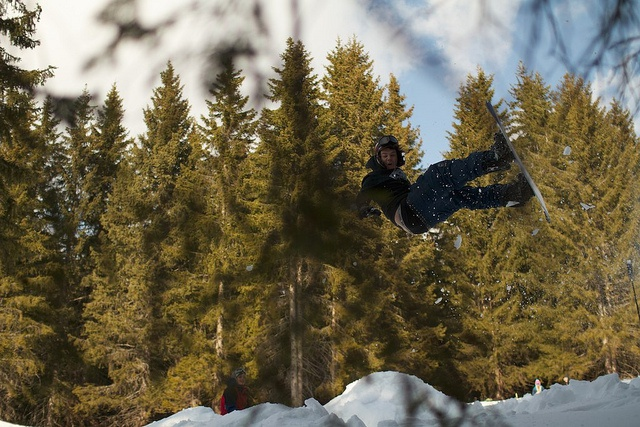Describe the objects in this image and their specific colors. I can see people in beige, black, gray, and olive tones and snowboard in beige, gray, darkgray, black, and olive tones in this image. 